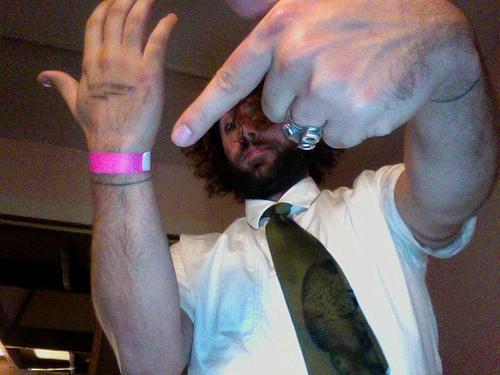How many people are there?
Give a very brief answer. 1. 